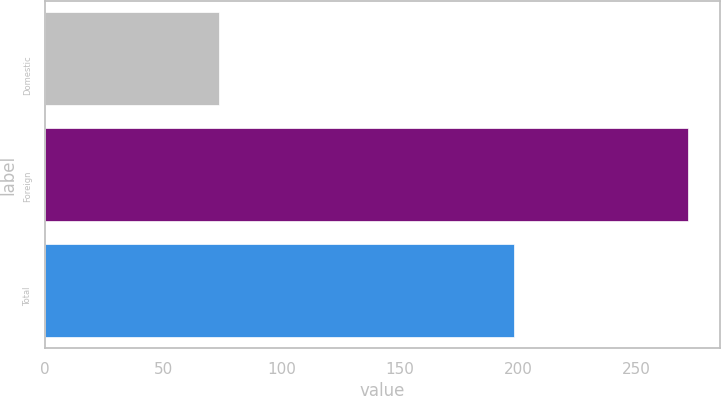<chart> <loc_0><loc_0><loc_500><loc_500><bar_chart><fcel>Domestic<fcel>Foreign<fcel>Total<nl><fcel>73.6<fcel>271.6<fcel>198<nl></chart> 